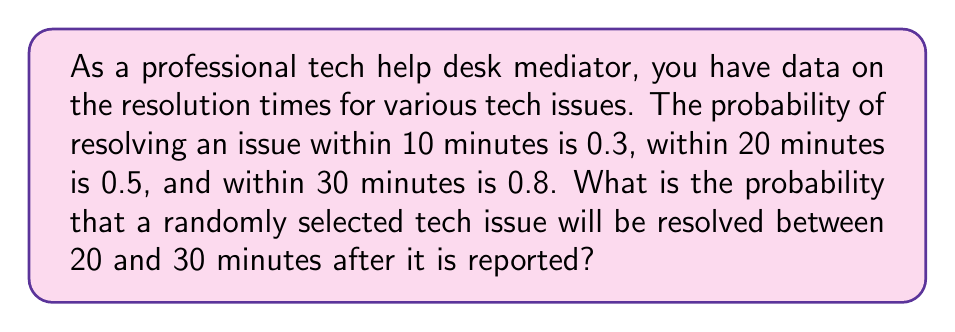What is the answer to this math problem? To solve this problem, we need to use the concept of probability and the given information. Let's break it down step by step:

1) Let's define our events:
   $A$ = issue resolved within 10 minutes
   $B$ = issue resolved within 20 minutes
   $C$ = issue resolved within 30 minutes

2) We're given the following probabilities:
   $P(A) = 0.3$
   $P(B) = 0.5$
   $P(C) = 0.8$

3) We want to find the probability of an issue being resolved between 20 and 30 minutes. This can be expressed as:
   $P(20 < X \leq 30)$, where $X$ is the time to resolve an issue.

4) We can calculate this by finding the difference between the probability of resolving within 30 minutes and the probability of resolving within 20 minutes:

   $P(20 < X \leq 30) = P(C) - P(B)$

5) Substituting the values:

   $P(20 < X \leq 30) = 0.8 - 0.5 = 0.3$

Therefore, the probability that a randomly selected tech issue will be resolved between 20 and 30 minutes after it is reported is 0.3 or 30%.
Answer: $0.3$ or $30\%$ 